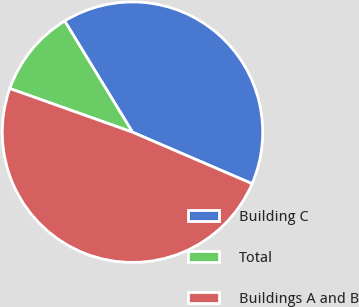<chart> <loc_0><loc_0><loc_500><loc_500><pie_chart><fcel>Building C<fcel>Total<fcel>Buildings A and B<nl><fcel>40.19%<fcel>10.84%<fcel>48.97%<nl></chart> 